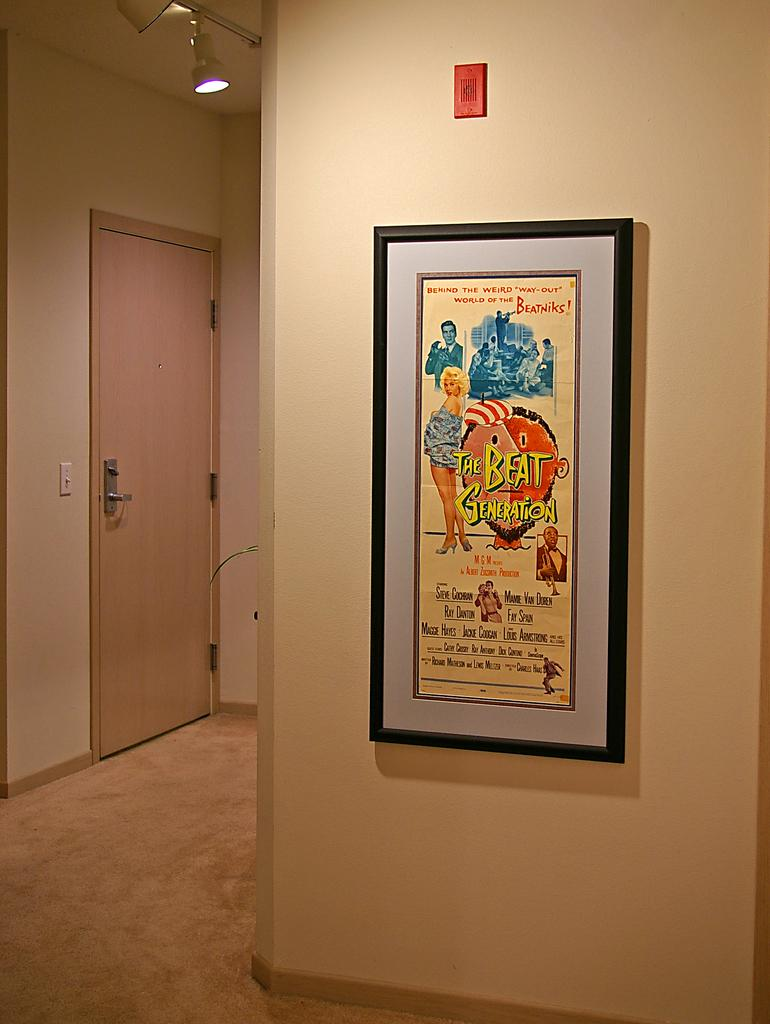Provide a one-sentence caption for the provided image. A poster hung on the wall displays The Beat Generation, Behind the Weird Way-Out of the Beatniks!. 